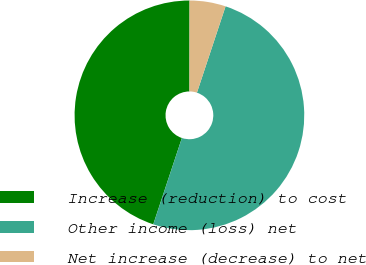Convert chart. <chart><loc_0><loc_0><loc_500><loc_500><pie_chart><fcel>Increase (reduction) to cost<fcel>Other income (loss) net<fcel>Net increase (decrease) to net<nl><fcel>44.92%<fcel>50.0%<fcel>5.08%<nl></chart> 